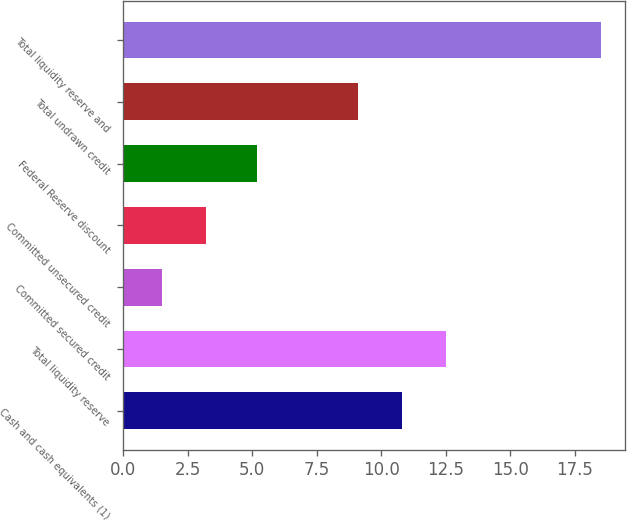<chart> <loc_0><loc_0><loc_500><loc_500><bar_chart><fcel>Cash and cash equivalents (1)<fcel>Total liquidity reserve<fcel>Committed secured credit<fcel>Committed unsecured credit<fcel>Federal Reserve discount<fcel>Total undrawn credit<fcel>Total liquidity reserve and<nl><fcel>10.8<fcel>12.5<fcel>1.5<fcel>3.2<fcel>5.2<fcel>9.1<fcel>18.5<nl></chart> 